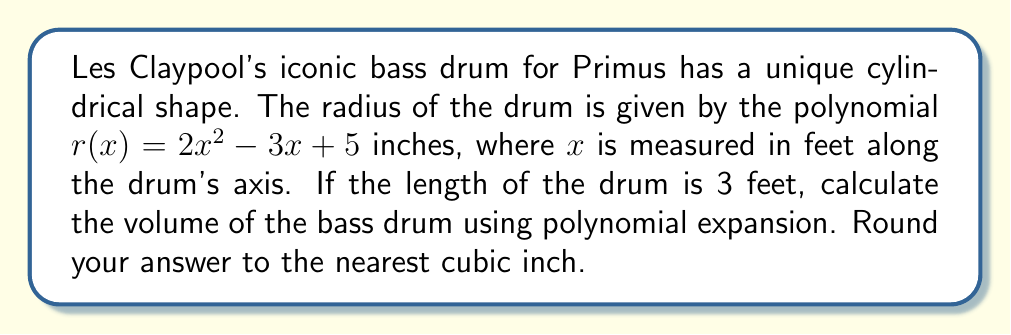Provide a solution to this math problem. To solve this problem, we'll follow these steps:

1) The volume of a cylinder is given by $V = \pi r^2 h$, where $r$ is the radius and $h$ is the height.

2) In this case, $r$ is a function of $x$, so we need to use the formula:

   $V = \pi \int_0^h [r(x)]^2 dx$

   where $h = 3$ feet (the length of the drum).

3) We need to square $r(x)$:

   $[r(x)]^2 = (2x^2 - 3x + 5)^2$
             $= 4x^4 - 12x^3 + 20x^2 + 9x^2 - 30x + 25$
             $= 4x^4 - 12x^3 + 29x^2 - 30x + 25$

4) Now we integrate this from 0 to 3:

   $V = \pi \int_0^3 (4x^4 - 12x^3 + 29x^2 - 30x + 25) dx$

5) Integrating term by term:

   $V = \pi [\frac{4x^5}{5} - 3x^4 + \frac{29x^3}{3} - 15x^2 + 25x]_0^3$

6) Evaluating at the limits:

   $V = \pi [(4\cdot3^5/5 - 3\cdot3^4 + 29\cdot3^3/3 - 15\cdot3^2 + 25\cdot3) - (0)]$
      $= \pi (432 - 243 + 261 - 135 + 75)$
      $= \pi \cdot 390$
      $\approx 1225.22$ cubic inches

7) Rounding to the nearest cubic inch:

   $V \approx 1225$ cubic inches
Answer: $1225$ cubic inches 